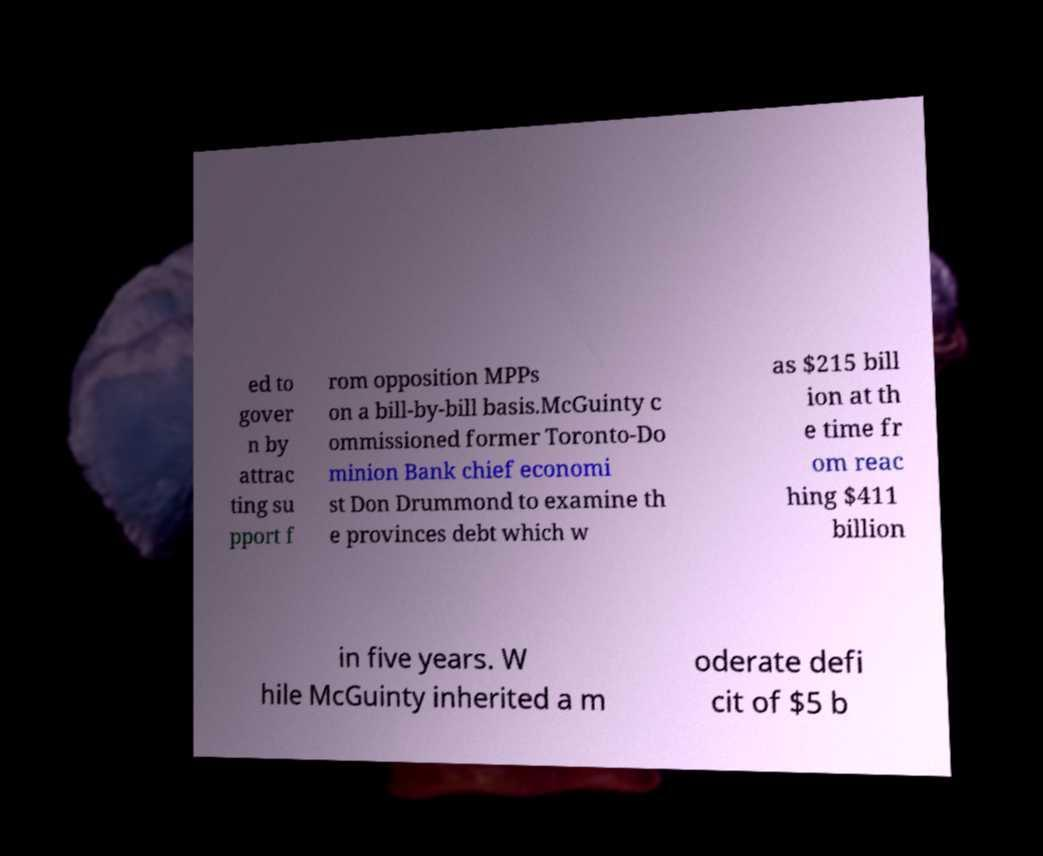What messages or text are displayed in this image? I need them in a readable, typed format. ed to gover n by attrac ting su pport f rom opposition MPPs on a bill-by-bill basis.McGuinty c ommissioned former Toronto-Do minion Bank chief economi st Don Drummond to examine th e provinces debt which w as $215 bill ion at th e time fr om reac hing $411 billion in five years. W hile McGuinty inherited a m oderate defi cit of $5 b 